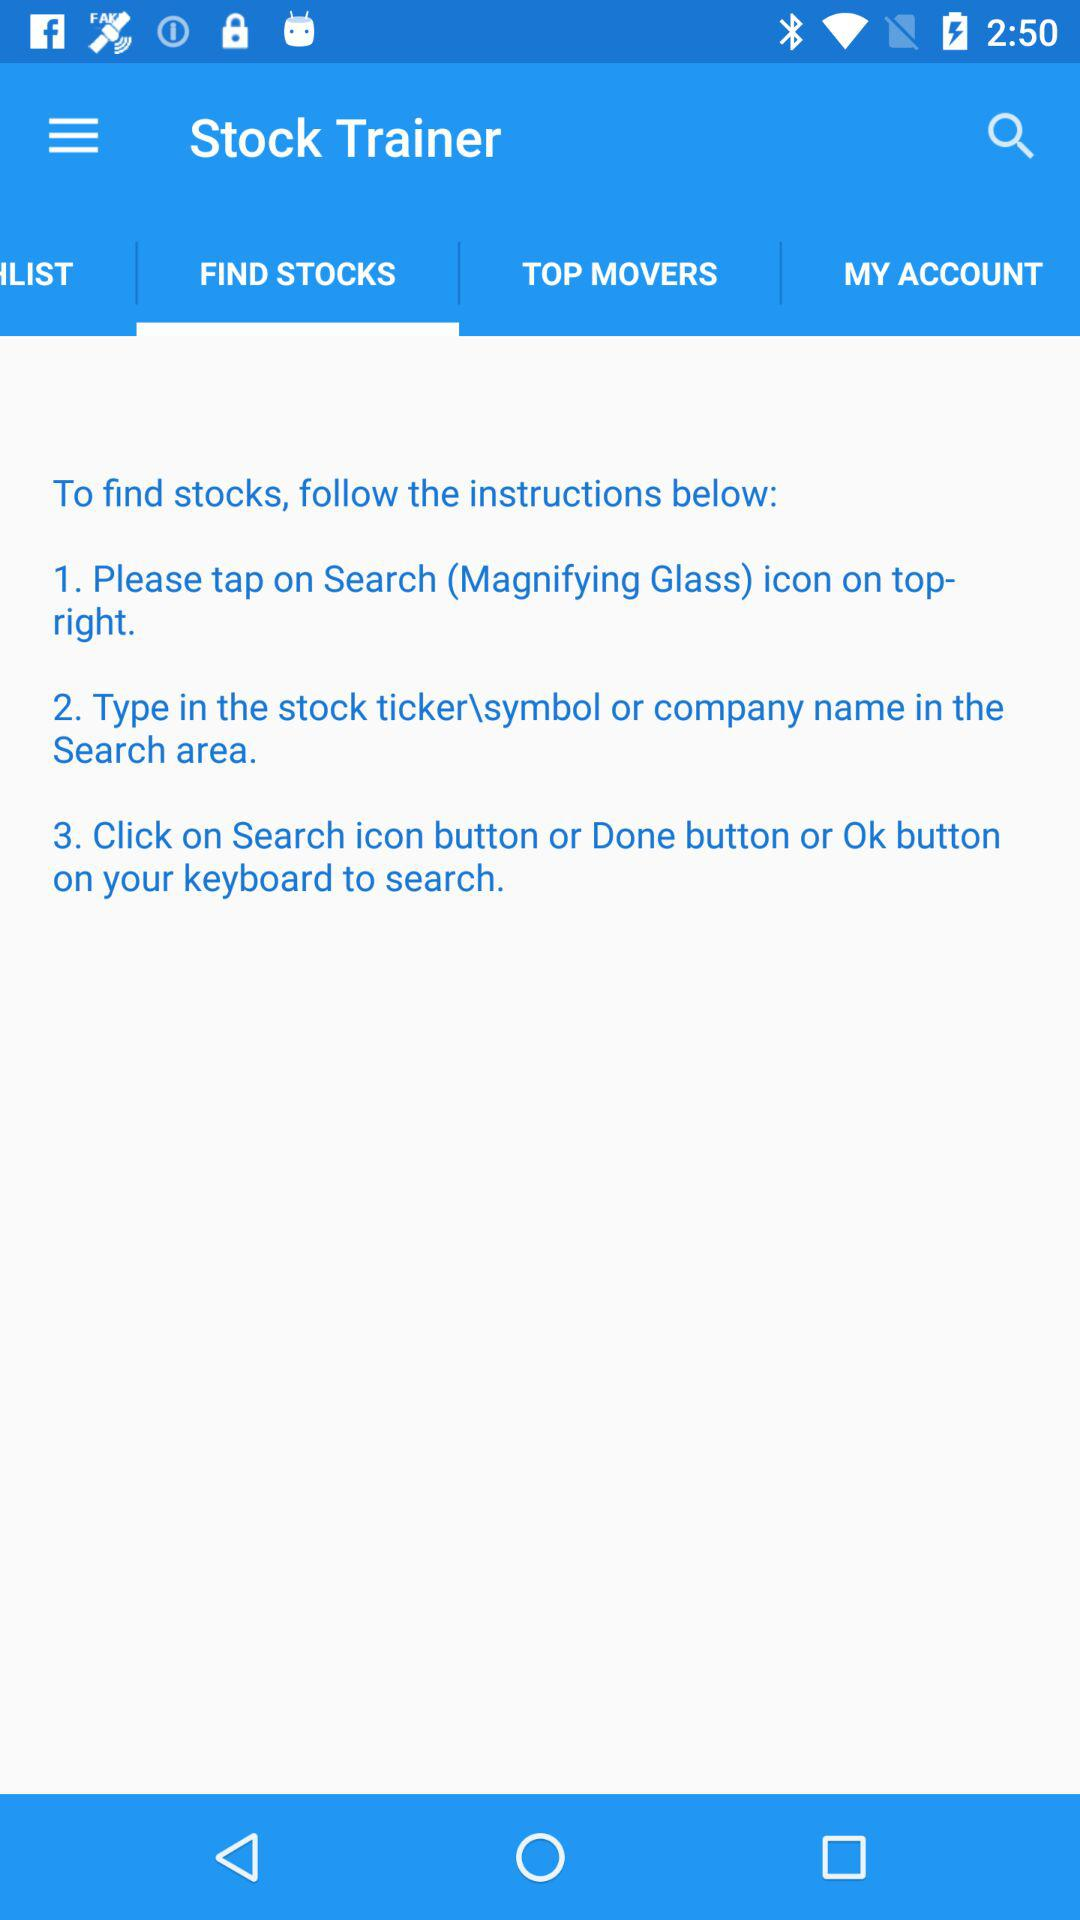How many instructions are there on how to find stocks?
Answer the question using a single word or phrase. 3 